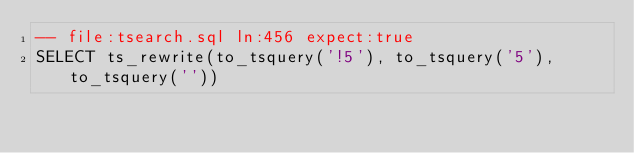Convert code to text. <code><loc_0><loc_0><loc_500><loc_500><_SQL_>-- file:tsearch.sql ln:456 expect:true
SELECT ts_rewrite(to_tsquery('!5'), to_tsquery('5'), to_tsquery(''))
</code> 